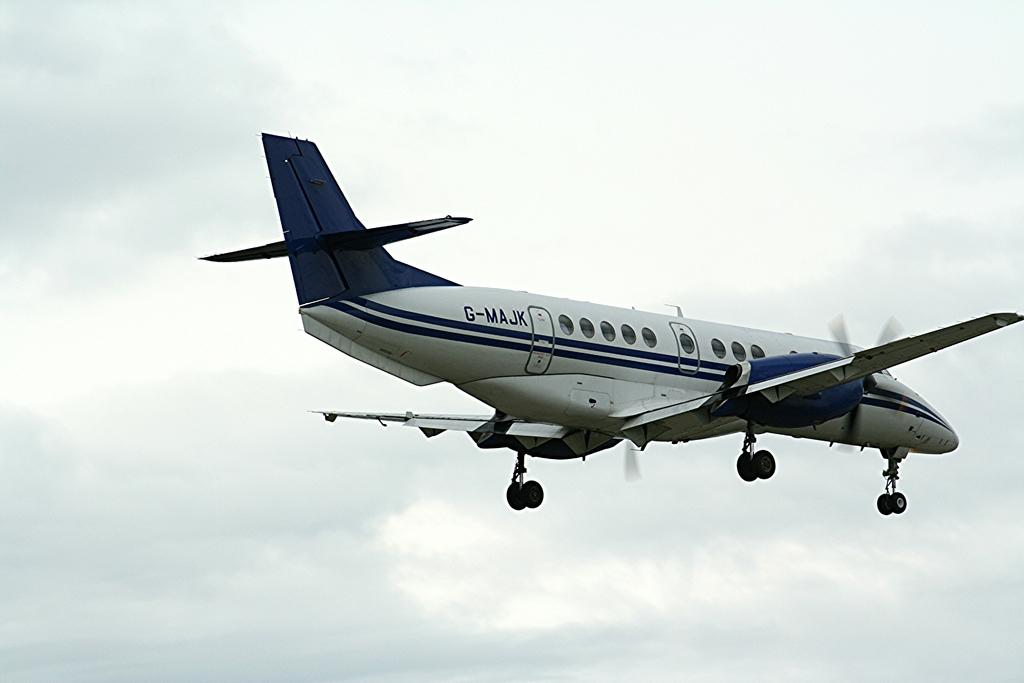Provide a one-sentence caption for the provided image. a small white and blue airplane with G-MAJK on its side. 